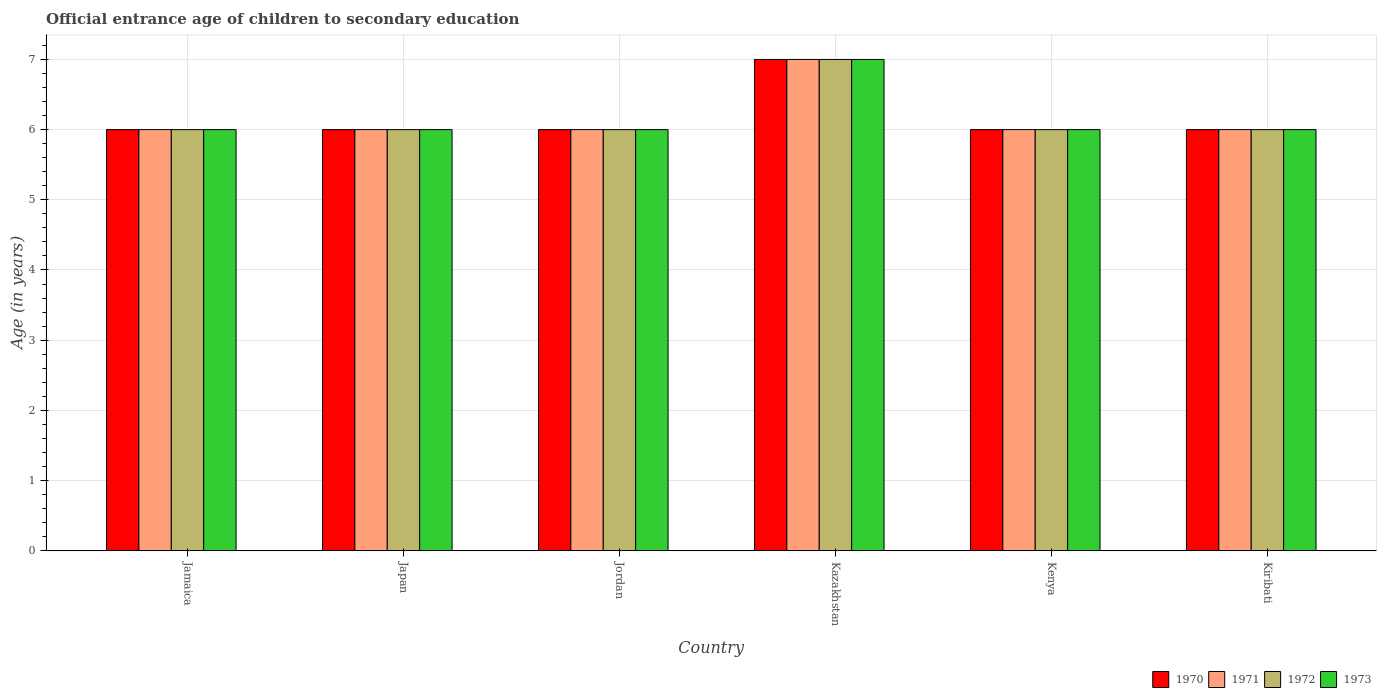How many bars are there on the 4th tick from the left?
Your response must be concise. 4. What is the label of the 1st group of bars from the left?
Offer a terse response. Jamaica. What is the secondary school starting age of children in 1972 in Kiribati?
Give a very brief answer. 6. Across all countries, what is the minimum secondary school starting age of children in 1973?
Your answer should be compact. 6. In which country was the secondary school starting age of children in 1971 maximum?
Provide a succinct answer. Kazakhstan. In which country was the secondary school starting age of children in 1970 minimum?
Your response must be concise. Jamaica. What is the total secondary school starting age of children in 1970 in the graph?
Your response must be concise. 37. What is the difference between the secondary school starting age of children in 1970 in Japan and that in Kenya?
Make the answer very short. 0. What is the difference between the secondary school starting age of children in 1971 in Jamaica and the secondary school starting age of children in 1972 in Jordan?
Your answer should be very brief. 0. What is the average secondary school starting age of children in 1973 per country?
Ensure brevity in your answer.  6.17. In how many countries, is the secondary school starting age of children in 1970 greater than 7 years?
Keep it short and to the point. 0. What is the ratio of the secondary school starting age of children in 1973 in Japan to that in Kiribati?
Your response must be concise. 1. Is the difference between the secondary school starting age of children in 1973 in Jamaica and Japan greater than the difference between the secondary school starting age of children in 1972 in Jamaica and Japan?
Provide a short and direct response. No. What is the difference between the highest and the lowest secondary school starting age of children in 1972?
Offer a very short reply. 1. In how many countries, is the secondary school starting age of children in 1972 greater than the average secondary school starting age of children in 1972 taken over all countries?
Give a very brief answer. 1. Is the sum of the secondary school starting age of children in 1970 in Jordan and Kiribati greater than the maximum secondary school starting age of children in 1971 across all countries?
Offer a terse response. Yes. Is it the case that in every country, the sum of the secondary school starting age of children in 1970 and secondary school starting age of children in 1971 is greater than the sum of secondary school starting age of children in 1973 and secondary school starting age of children in 1972?
Give a very brief answer. No. What does the 2nd bar from the right in Kiribati represents?
Provide a succinct answer. 1972. How many bars are there?
Make the answer very short. 24. Are the values on the major ticks of Y-axis written in scientific E-notation?
Keep it short and to the point. No. Does the graph contain any zero values?
Keep it short and to the point. No. Where does the legend appear in the graph?
Ensure brevity in your answer.  Bottom right. How are the legend labels stacked?
Offer a terse response. Horizontal. What is the title of the graph?
Give a very brief answer. Official entrance age of children to secondary education. Does "1995" appear as one of the legend labels in the graph?
Offer a terse response. No. What is the label or title of the Y-axis?
Offer a terse response. Age (in years). What is the Age (in years) in 1970 in Jamaica?
Your answer should be compact. 6. What is the Age (in years) in 1973 in Jamaica?
Provide a short and direct response. 6. What is the Age (in years) in 1970 in Japan?
Give a very brief answer. 6. What is the Age (in years) of 1972 in Japan?
Give a very brief answer. 6. What is the Age (in years) in 1973 in Japan?
Your response must be concise. 6. What is the Age (in years) of 1970 in Jordan?
Give a very brief answer. 6. What is the Age (in years) in 1972 in Jordan?
Offer a terse response. 6. What is the Age (in years) in 1970 in Kazakhstan?
Ensure brevity in your answer.  7. What is the Age (in years) in 1971 in Kazakhstan?
Keep it short and to the point. 7. What is the Age (in years) in 1972 in Kazakhstan?
Your answer should be very brief. 7. What is the Age (in years) of 1973 in Kazakhstan?
Give a very brief answer. 7. What is the Age (in years) of 1972 in Kenya?
Ensure brevity in your answer.  6. What is the Age (in years) in 1973 in Kenya?
Your answer should be compact. 6. What is the Age (in years) in 1970 in Kiribati?
Offer a terse response. 6. What is the Age (in years) in 1973 in Kiribati?
Ensure brevity in your answer.  6. Across all countries, what is the maximum Age (in years) in 1971?
Give a very brief answer. 7. Across all countries, what is the minimum Age (in years) of 1971?
Your answer should be very brief. 6. Across all countries, what is the minimum Age (in years) of 1972?
Your answer should be very brief. 6. What is the total Age (in years) in 1972 in the graph?
Make the answer very short. 37. What is the total Age (in years) in 1973 in the graph?
Provide a short and direct response. 37. What is the difference between the Age (in years) of 1970 in Jamaica and that in Japan?
Provide a short and direct response. 0. What is the difference between the Age (in years) in 1973 in Jamaica and that in Japan?
Make the answer very short. 0. What is the difference between the Age (in years) of 1970 in Jamaica and that in Jordan?
Provide a succinct answer. 0. What is the difference between the Age (in years) of 1971 in Jamaica and that in Jordan?
Your answer should be very brief. 0. What is the difference between the Age (in years) in 1970 in Jamaica and that in Kazakhstan?
Keep it short and to the point. -1. What is the difference between the Age (in years) in 1973 in Jamaica and that in Kenya?
Your response must be concise. 0. What is the difference between the Age (in years) in 1971 in Jamaica and that in Kiribati?
Offer a very short reply. 0. What is the difference between the Age (in years) in 1971 in Japan and that in Jordan?
Provide a succinct answer. 0. What is the difference between the Age (in years) of 1973 in Japan and that in Jordan?
Your answer should be compact. 0. What is the difference between the Age (in years) of 1971 in Japan and that in Kazakhstan?
Keep it short and to the point. -1. What is the difference between the Age (in years) of 1972 in Japan and that in Kazakhstan?
Your answer should be very brief. -1. What is the difference between the Age (in years) in 1973 in Japan and that in Kenya?
Give a very brief answer. 0. What is the difference between the Age (in years) of 1970 in Japan and that in Kiribati?
Your answer should be compact. 0. What is the difference between the Age (in years) of 1971 in Japan and that in Kiribati?
Give a very brief answer. 0. What is the difference between the Age (in years) of 1972 in Japan and that in Kiribati?
Your answer should be very brief. 0. What is the difference between the Age (in years) of 1970 in Jordan and that in Kazakhstan?
Keep it short and to the point. -1. What is the difference between the Age (in years) of 1971 in Jordan and that in Kazakhstan?
Offer a very short reply. -1. What is the difference between the Age (in years) of 1973 in Jordan and that in Kazakhstan?
Provide a short and direct response. -1. What is the difference between the Age (in years) in 1973 in Jordan and that in Kenya?
Keep it short and to the point. 0. What is the difference between the Age (in years) in 1970 in Jordan and that in Kiribati?
Provide a short and direct response. 0. What is the difference between the Age (in years) of 1971 in Jordan and that in Kiribati?
Provide a succinct answer. 0. What is the difference between the Age (in years) in 1972 in Jordan and that in Kiribati?
Provide a short and direct response. 0. What is the difference between the Age (in years) of 1970 in Kazakhstan and that in Kenya?
Provide a short and direct response. 1. What is the difference between the Age (in years) in 1971 in Kazakhstan and that in Kenya?
Offer a terse response. 1. What is the difference between the Age (in years) of 1973 in Kazakhstan and that in Kenya?
Your answer should be compact. 1. What is the difference between the Age (in years) in 1972 in Kazakhstan and that in Kiribati?
Your response must be concise. 1. What is the difference between the Age (in years) in 1971 in Kenya and that in Kiribati?
Make the answer very short. 0. What is the difference between the Age (in years) in 1973 in Kenya and that in Kiribati?
Your response must be concise. 0. What is the difference between the Age (in years) in 1970 in Jamaica and the Age (in years) in 1973 in Japan?
Your response must be concise. 0. What is the difference between the Age (in years) in 1970 in Jamaica and the Age (in years) in 1971 in Jordan?
Your answer should be very brief. 0. What is the difference between the Age (in years) in 1970 in Jamaica and the Age (in years) in 1972 in Jordan?
Offer a very short reply. 0. What is the difference between the Age (in years) of 1971 in Jamaica and the Age (in years) of 1972 in Jordan?
Keep it short and to the point. 0. What is the difference between the Age (in years) in 1971 in Jamaica and the Age (in years) in 1973 in Jordan?
Your answer should be compact. 0. What is the difference between the Age (in years) in 1972 in Jamaica and the Age (in years) in 1973 in Jordan?
Give a very brief answer. 0. What is the difference between the Age (in years) of 1970 in Jamaica and the Age (in years) of 1973 in Kazakhstan?
Your answer should be very brief. -1. What is the difference between the Age (in years) in 1970 in Jamaica and the Age (in years) in 1973 in Kenya?
Give a very brief answer. 0. What is the difference between the Age (in years) of 1971 in Jamaica and the Age (in years) of 1973 in Kenya?
Provide a succinct answer. 0. What is the difference between the Age (in years) in 1970 in Jamaica and the Age (in years) in 1971 in Kiribati?
Ensure brevity in your answer.  0. What is the difference between the Age (in years) of 1970 in Jamaica and the Age (in years) of 1973 in Kiribati?
Provide a succinct answer. 0. What is the difference between the Age (in years) in 1971 in Jamaica and the Age (in years) in 1972 in Kiribati?
Your response must be concise. 0. What is the difference between the Age (in years) in 1971 in Jamaica and the Age (in years) in 1973 in Kiribati?
Provide a short and direct response. 0. What is the difference between the Age (in years) in 1970 in Japan and the Age (in years) in 1971 in Jordan?
Ensure brevity in your answer.  0. What is the difference between the Age (in years) of 1970 in Japan and the Age (in years) of 1973 in Jordan?
Offer a terse response. 0. What is the difference between the Age (in years) in 1971 in Japan and the Age (in years) in 1973 in Jordan?
Provide a short and direct response. 0. What is the difference between the Age (in years) of 1972 in Japan and the Age (in years) of 1973 in Jordan?
Provide a succinct answer. 0. What is the difference between the Age (in years) of 1970 in Japan and the Age (in years) of 1971 in Kazakhstan?
Offer a terse response. -1. What is the difference between the Age (in years) in 1970 in Japan and the Age (in years) in 1973 in Kazakhstan?
Offer a very short reply. -1. What is the difference between the Age (in years) of 1972 in Japan and the Age (in years) of 1973 in Kazakhstan?
Your response must be concise. -1. What is the difference between the Age (in years) in 1970 in Japan and the Age (in years) in 1971 in Kenya?
Provide a succinct answer. 0. What is the difference between the Age (in years) in 1970 in Japan and the Age (in years) in 1973 in Kenya?
Give a very brief answer. 0. What is the difference between the Age (in years) of 1971 in Japan and the Age (in years) of 1972 in Kenya?
Your answer should be very brief. 0. What is the difference between the Age (in years) in 1971 in Japan and the Age (in years) in 1973 in Kenya?
Keep it short and to the point. 0. What is the difference between the Age (in years) in 1972 in Japan and the Age (in years) in 1973 in Kenya?
Provide a succinct answer. 0. What is the difference between the Age (in years) in 1971 in Japan and the Age (in years) in 1972 in Kiribati?
Provide a short and direct response. 0. What is the difference between the Age (in years) in 1971 in Japan and the Age (in years) in 1973 in Kiribati?
Your answer should be very brief. 0. What is the difference between the Age (in years) of 1972 in Japan and the Age (in years) of 1973 in Kiribati?
Provide a short and direct response. 0. What is the difference between the Age (in years) of 1970 in Jordan and the Age (in years) of 1972 in Kazakhstan?
Offer a terse response. -1. What is the difference between the Age (in years) of 1970 in Jordan and the Age (in years) of 1973 in Kazakhstan?
Your response must be concise. -1. What is the difference between the Age (in years) in 1971 in Jordan and the Age (in years) in 1973 in Kazakhstan?
Your answer should be very brief. -1. What is the difference between the Age (in years) in 1972 in Jordan and the Age (in years) in 1973 in Kazakhstan?
Make the answer very short. -1. What is the difference between the Age (in years) of 1971 in Jordan and the Age (in years) of 1972 in Kenya?
Make the answer very short. 0. What is the difference between the Age (in years) of 1972 in Jordan and the Age (in years) of 1973 in Kenya?
Your answer should be very brief. 0. What is the difference between the Age (in years) of 1970 in Jordan and the Age (in years) of 1973 in Kiribati?
Your answer should be compact. 0. What is the difference between the Age (in years) in 1971 in Jordan and the Age (in years) in 1972 in Kiribati?
Make the answer very short. 0. What is the difference between the Age (in years) of 1971 in Jordan and the Age (in years) of 1973 in Kiribati?
Provide a succinct answer. 0. What is the difference between the Age (in years) of 1970 in Kazakhstan and the Age (in years) of 1972 in Kenya?
Provide a succinct answer. 1. What is the difference between the Age (in years) of 1970 in Kazakhstan and the Age (in years) of 1972 in Kiribati?
Your answer should be compact. 1. What is the difference between the Age (in years) in 1971 in Kazakhstan and the Age (in years) in 1972 in Kiribati?
Give a very brief answer. 1. What is the difference between the Age (in years) in 1972 in Kazakhstan and the Age (in years) in 1973 in Kiribati?
Your answer should be compact. 1. What is the difference between the Age (in years) in 1970 in Kenya and the Age (in years) in 1971 in Kiribati?
Your answer should be very brief. 0. What is the difference between the Age (in years) in 1970 in Kenya and the Age (in years) in 1972 in Kiribati?
Give a very brief answer. 0. What is the difference between the Age (in years) in 1970 in Kenya and the Age (in years) in 1973 in Kiribati?
Ensure brevity in your answer.  0. What is the difference between the Age (in years) in 1971 in Kenya and the Age (in years) in 1973 in Kiribati?
Provide a short and direct response. 0. What is the average Age (in years) of 1970 per country?
Make the answer very short. 6.17. What is the average Age (in years) of 1971 per country?
Make the answer very short. 6.17. What is the average Age (in years) of 1972 per country?
Provide a succinct answer. 6.17. What is the average Age (in years) of 1973 per country?
Give a very brief answer. 6.17. What is the difference between the Age (in years) of 1970 and Age (in years) of 1973 in Jamaica?
Offer a terse response. 0. What is the difference between the Age (in years) of 1971 and Age (in years) of 1972 in Jamaica?
Give a very brief answer. 0. What is the difference between the Age (in years) of 1971 and Age (in years) of 1973 in Jamaica?
Give a very brief answer. 0. What is the difference between the Age (in years) of 1971 and Age (in years) of 1973 in Japan?
Make the answer very short. 0. What is the difference between the Age (in years) of 1970 and Age (in years) of 1972 in Jordan?
Your response must be concise. 0. What is the difference between the Age (in years) in 1970 and Age (in years) in 1973 in Jordan?
Provide a succinct answer. 0. What is the difference between the Age (in years) of 1971 and Age (in years) of 1972 in Jordan?
Give a very brief answer. 0. What is the difference between the Age (in years) in 1972 and Age (in years) in 1973 in Jordan?
Your answer should be very brief. 0. What is the difference between the Age (in years) in 1971 and Age (in years) in 1972 in Kazakhstan?
Make the answer very short. 0. What is the difference between the Age (in years) of 1971 and Age (in years) of 1973 in Kazakhstan?
Make the answer very short. 0. What is the difference between the Age (in years) in 1970 and Age (in years) in 1972 in Kenya?
Offer a terse response. 0. What is the difference between the Age (in years) in 1970 and Age (in years) in 1973 in Kenya?
Provide a short and direct response. 0. What is the difference between the Age (in years) in 1971 and Age (in years) in 1972 in Kenya?
Your response must be concise. 0. What is the difference between the Age (in years) of 1971 and Age (in years) of 1973 in Kenya?
Keep it short and to the point. 0. What is the difference between the Age (in years) in 1972 and Age (in years) in 1973 in Kenya?
Your answer should be very brief. 0. What is the difference between the Age (in years) in 1970 and Age (in years) in 1971 in Kiribati?
Provide a succinct answer. 0. What is the difference between the Age (in years) of 1970 and Age (in years) of 1972 in Kiribati?
Provide a succinct answer. 0. What is the difference between the Age (in years) of 1970 and Age (in years) of 1973 in Kiribati?
Your answer should be compact. 0. What is the difference between the Age (in years) of 1971 and Age (in years) of 1973 in Kiribati?
Your answer should be very brief. 0. What is the ratio of the Age (in years) in 1970 in Jamaica to that in Japan?
Give a very brief answer. 1. What is the ratio of the Age (in years) of 1972 in Jamaica to that in Japan?
Offer a very short reply. 1. What is the ratio of the Age (in years) in 1970 in Jamaica to that in Jordan?
Ensure brevity in your answer.  1. What is the ratio of the Age (in years) in 1972 in Jamaica to that in Jordan?
Offer a terse response. 1. What is the ratio of the Age (in years) of 1970 in Jamaica to that in Kazakhstan?
Ensure brevity in your answer.  0.86. What is the ratio of the Age (in years) of 1971 in Jamaica to that in Kenya?
Offer a terse response. 1. What is the ratio of the Age (in years) of 1972 in Jamaica to that in Kenya?
Ensure brevity in your answer.  1. What is the ratio of the Age (in years) of 1973 in Jamaica to that in Kenya?
Keep it short and to the point. 1. What is the ratio of the Age (in years) in 1973 in Jamaica to that in Kiribati?
Provide a short and direct response. 1. What is the ratio of the Age (in years) of 1970 in Japan to that in Jordan?
Offer a very short reply. 1. What is the ratio of the Age (in years) in 1971 in Japan to that in Jordan?
Your answer should be compact. 1. What is the ratio of the Age (in years) in 1972 in Japan to that in Jordan?
Ensure brevity in your answer.  1. What is the ratio of the Age (in years) in 1972 in Japan to that in Kazakhstan?
Provide a short and direct response. 0.86. What is the ratio of the Age (in years) of 1970 in Japan to that in Kenya?
Make the answer very short. 1. What is the ratio of the Age (in years) of 1971 in Japan to that in Kenya?
Ensure brevity in your answer.  1. What is the ratio of the Age (in years) in 1973 in Japan to that in Kenya?
Your response must be concise. 1. What is the ratio of the Age (in years) of 1970 in Japan to that in Kiribati?
Your response must be concise. 1. What is the ratio of the Age (in years) in 1972 in Japan to that in Kiribati?
Your response must be concise. 1. What is the ratio of the Age (in years) in 1970 in Jordan to that in Kenya?
Your answer should be very brief. 1. What is the ratio of the Age (in years) of 1972 in Jordan to that in Kenya?
Offer a very short reply. 1. What is the ratio of the Age (in years) of 1973 in Jordan to that in Kenya?
Ensure brevity in your answer.  1. What is the ratio of the Age (in years) in 1970 in Jordan to that in Kiribati?
Provide a short and direct response. 1. What is the ratio of the Age (in years) in 1971 in Jordan to that in Kiribati?
Make the answer very short. 1. What is the ratio of the Age (in years) in 1970 in Kazakhstan to that in Kenya?
Keep it short and to the point. 1.17. What is the ratio of the Age (in years) in 1971 in Kazakhstan to that in Kenya?
Your answer should be very brief. 1.17. What is the ratio of the Age (in years) of 1972 in Kazakhstan to that in Kenya?
Offer a terse response. 1.17. What is the ratio of the Age (in years) in 1971 in Kazakhstan to that in Kiribati?
Your answer should be very brief. 1.17. What is the ratio of the Age (in years) in 1972 in Kazakhstan to that in Kiribati?
Offer a very short reply. 1.17. What is the ratio of the Age (in years) in 1973 in Kazakhstan to that in Kiribati?
Your response must be concise. 1.17. What is the ratio of the Age (in years) of 1971 in Kenya to that in Kiribati?
Give a very brief answer. 1. What is the difference between the highest and the second highest Age (in years) of 1971?
Your answer should be very brief. 1. What is the difference between the highest and the second highest Age (in years) in 1973?
Provide a short and direct response. 1. 